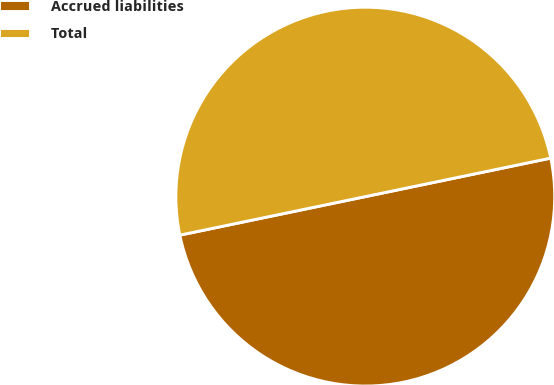<chart> <loc_0><loc_0><loc_500><loc_500><pie_chart><fcel>Accrued liabilities<fcel>Total<nl><fcel>50.0%<fcel>50.0%<nl></chart> 